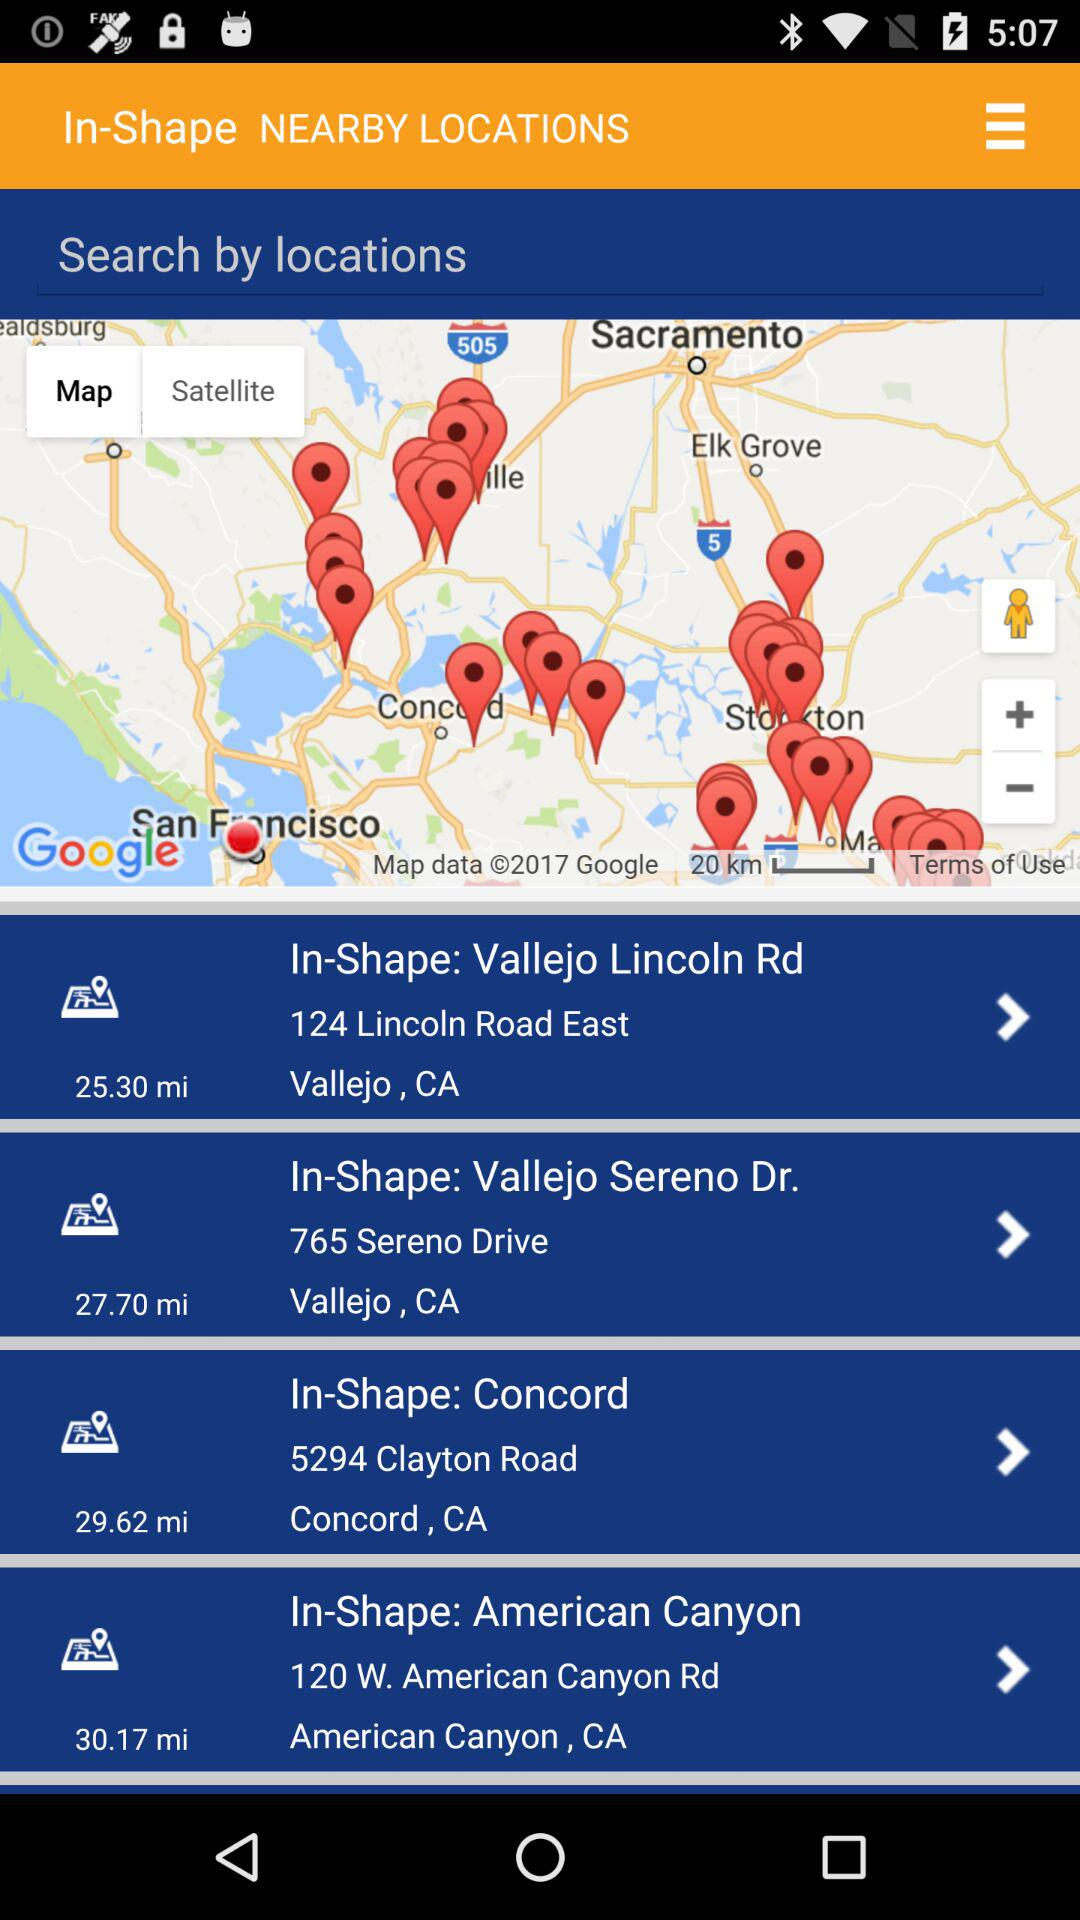How many miles is the longest distance between two locations?
Answer the question using a single word or phrase. 30.17 